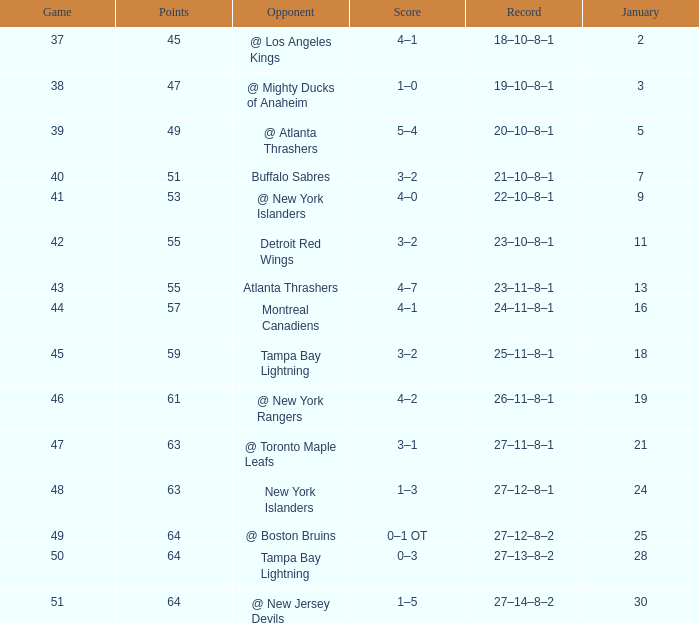Could you parse the entire table? {'header': ['Game', 'Points', 'Opponent', 'Score', 'Record', 'January'], 'rows': [['37', '45', '@ Los Angeles Kings', '4–1', '18–10–8–1', '2'], ['38', '47', '@ Mighty Ducks of Anaheim', '1–0', '19–10–8–1', '3'], ['39', '49', '@ Atlanta Thrashers', '5–4', '20–10–8–1', '5'], ['40', '51', 'Buffalo Sabres', '3–2', '21–10–8–1', '7'], ['41', '53', '@ New York Islanders', '4–0', '22–10–8–1', '9'], ['42', '55', 'Detroit Red Wings', '3–2', '23–10–8–1', '11'], ['43', '55', 'Atlanta Thrashers', '4–7', '23–11–8–1', '13'], ['44', '57', 'Montreal Canadiens', '4–1', '24–11–8–1', '16'], ['45', '59', 'Tampa Bay Lightning', '3–2', '25–11–8–1', '18'], ['46', '61', '@ New York Rangers', '4–2', '26–11–8–1', '19'], ['47', '63', '@ Toronto Maple Leafs', '3–1', '27–11–8–1', '21'], ['48', '63', 'New York Islanders', '1–3', '27–12–8–1', '24'], ['49', '64', '@ Boston Bruins', '0–1 OT', '27–12–8–2', '25'], ['50', '64', 'Tampa Bay Lightning', '0–3', '27–13–8–2', '28'], ['51', '64', '@ New Jersey Devils', '1–5', '27–14–8–2', '30']]} How many Points have a January of 18? 1.0. 